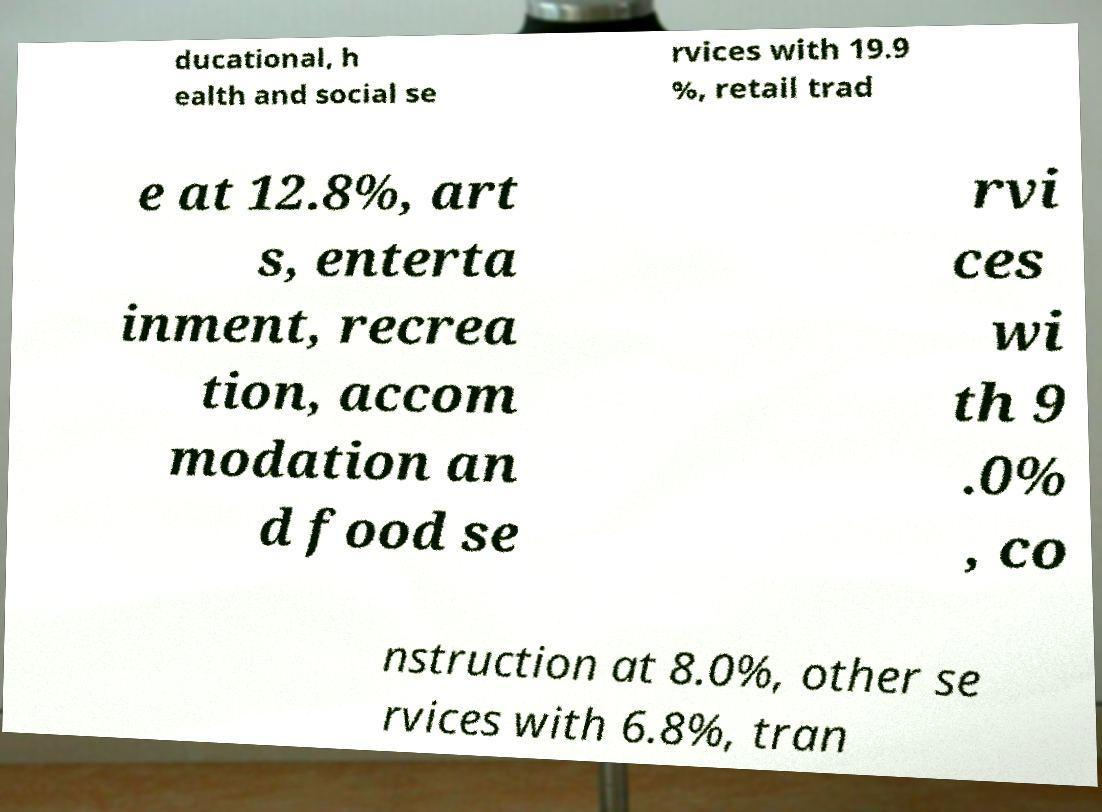Can you read and provide the text displayed in the image?This photo seems to have some interesting text. Can you extract and type it out for me? ducational, h ealth and social se rvices with 19.9 %, retail trad e at 12.8%, art s, enterta inment, recrea tion, accom modation an d food se rvi ces wi th 9 .0% , co nstruction at 8.0%, other se rvices with 6.8%, tran 